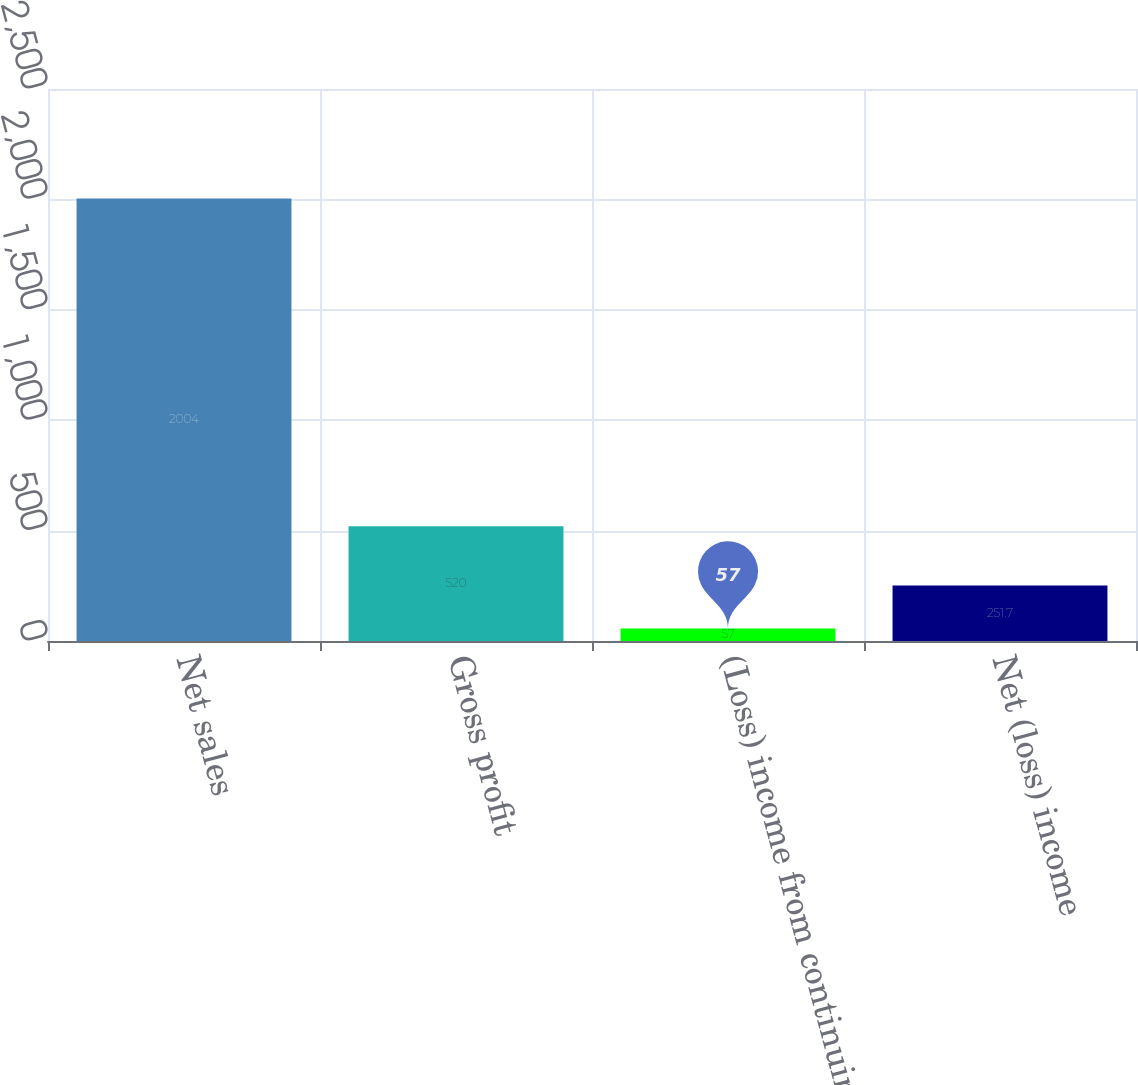Convert chart to OTSL. <chart><loc_0><loc_0><loc_500><loc_500><bar_chart><fcel>Net sales<fcel>Gross profit<fcel>(Loss) income from continuing<fcel>Net (loss) income<nl><fcel>2004<fcel>520<fcel>57<fcel>251.7<nl></chart> 